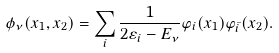<formula> <loc_0><loc_0><loc_500><loc_500>\phi _ { \nu } ( x _ { 1 } , x _ { 2 } ) = \sum _ { i } \frac { 1 } { 2 \varepsilon _ { i } - E _ { \nu } } \varphi _ { i } ( x _ { 1 } ) \varphi _ { \bar { i } } ( x _ { 2 } ) .</formula> 